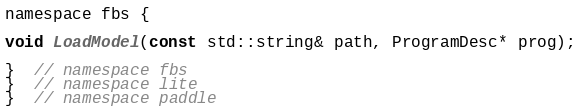Convert code to text. <code><loc_0><loc_0><loc_500><loc_500><_C_>namespace fbs {

void LoadModel(const std::string& path, ProgramDesc* prog);

}  // namespace fbs
}  // namespace lite
}  // namespace paddle
</code> 